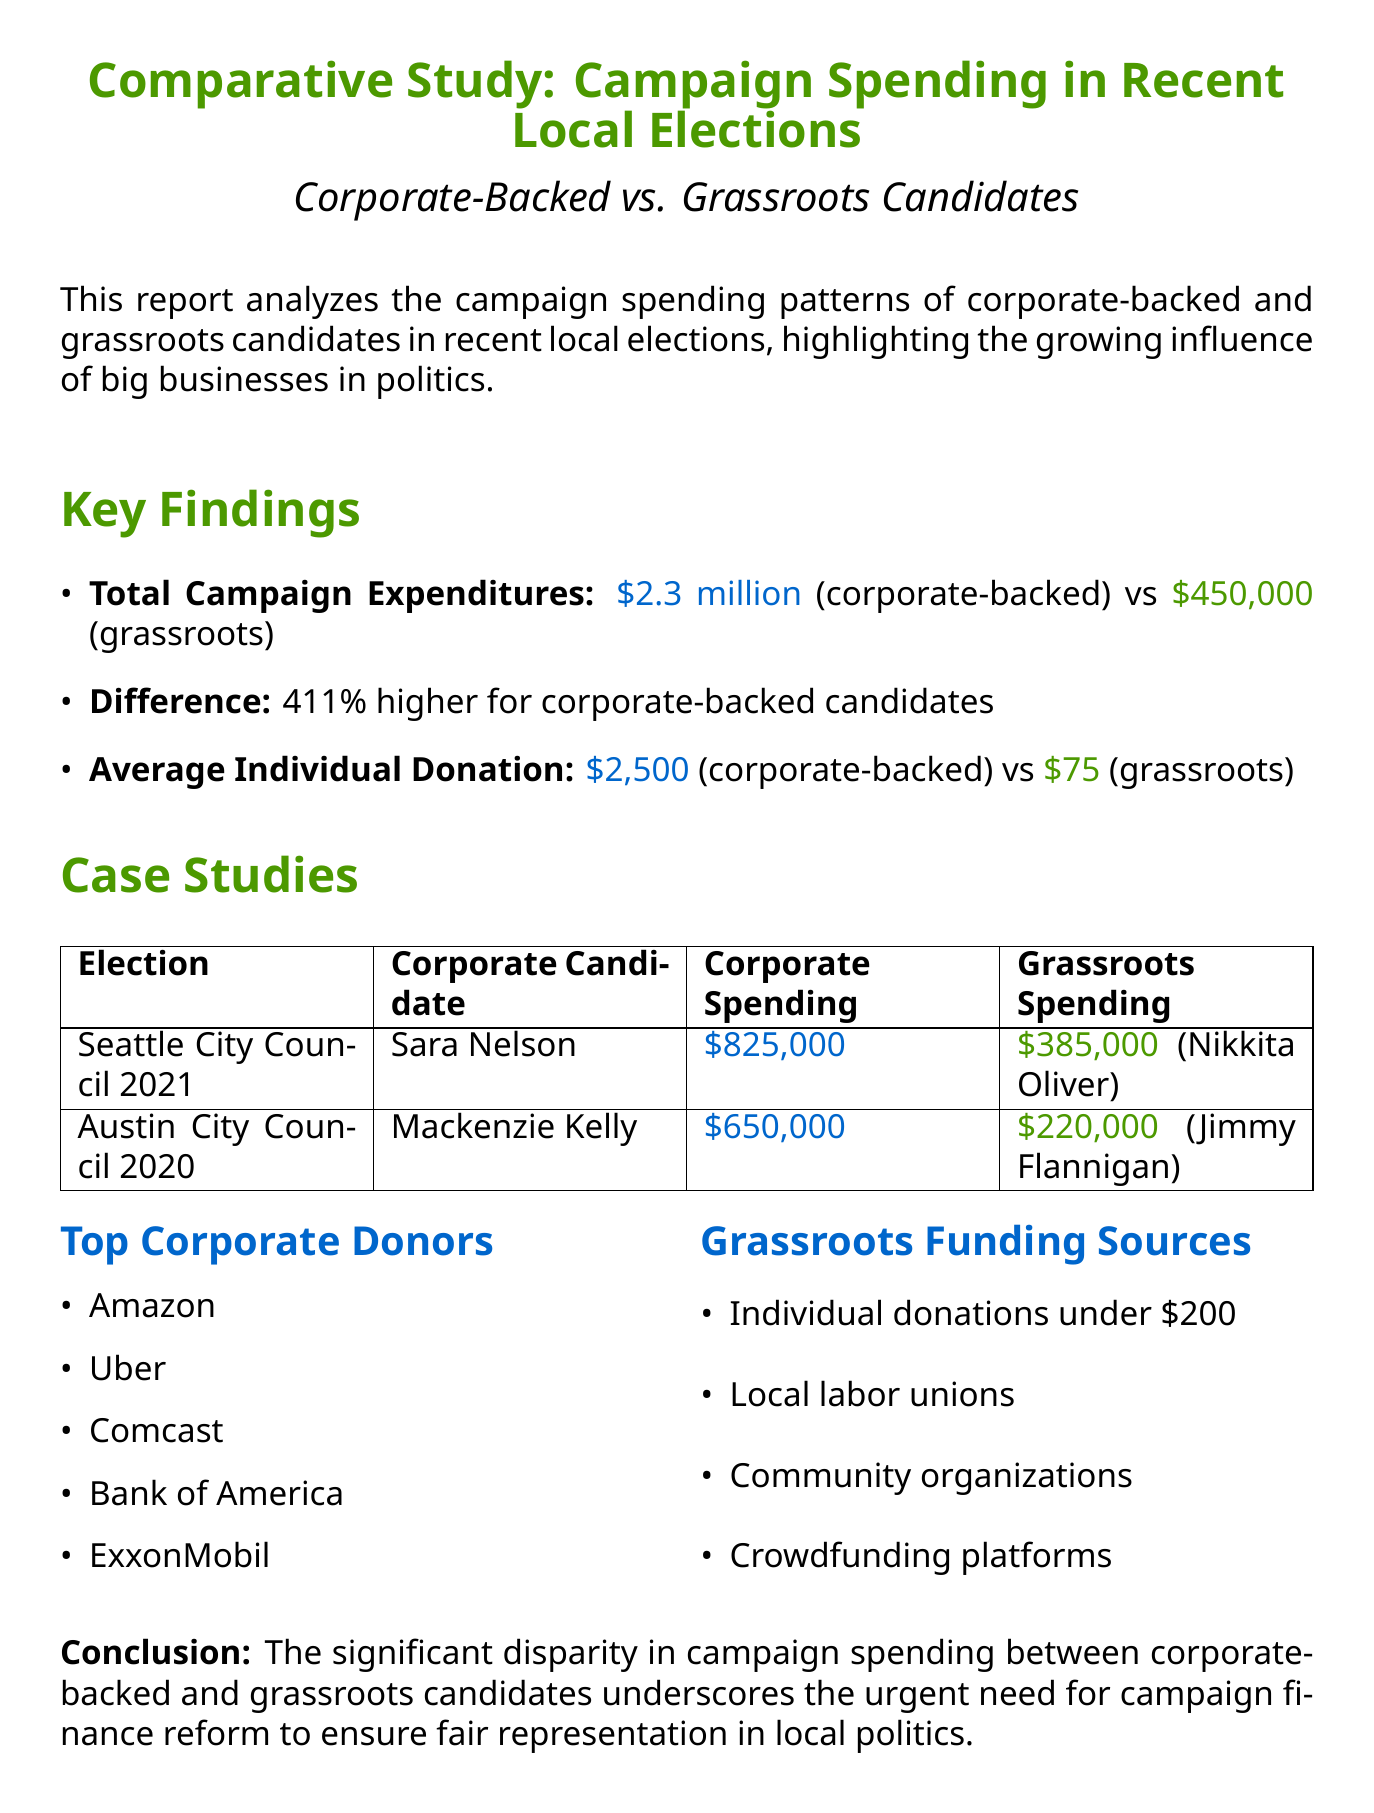What is the total campaign expenditure for corporate-backed candidates? The total campaign expenditure for corporate-backed candidates is stated in the document as $2.3 million.
Answer: $2.3 million What is the total campaign expenditure for grassroots candidates? The total campaign expenditure for grassroots candidates is mentioned as $450,000 in the document.
Answer: $450,000 What is the percentage difference in spending between corporate-backed and grassroots candidates? The document indicates that corporate-backed candidates spent 411% more than grassroots candidates.
Answer: 411% Who was the corporate-backed candidate in the Seattle City Council 2021 election? The document specifies that Sara Nelson was the corporate-backed candidate in this election.
Answer: Sara Nelson What was the average individual donation for grassroots candidates? According to the report, the average individual donation for grassroots candidates is $75.
Answer: $75 Which company topped the list of corporate donors? The report lists Amazon as one of the top corporate donors.
Answer: Amazon What funding sources do grassroots candidates rely on? The document enumerates various sources, including individual donations under $200 and local labor unions, that grassroots candidates depend on.
Answer: Individual donations under $200 What conclusion does the report emphasize regarding campaign finance? The conclusion of the report highlights the urgent need for campaign finance reform to address the disparity in spending.
Answer: Urgent need for campaign finance reform 